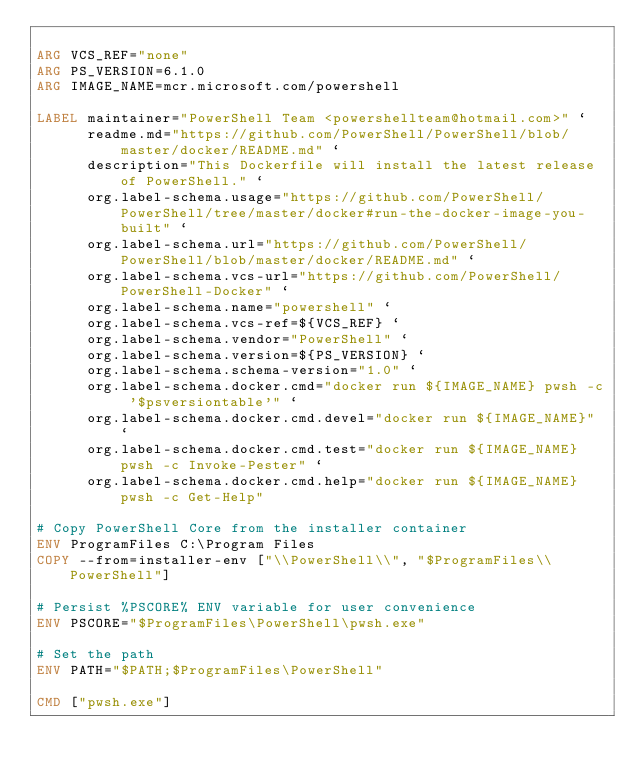<code> <loc_0><loc_0><loc_500><loc_500><_Dockerfile_>
ARG VCS_REF="none"
ARG PS_VERSION=6.1.0
ARG IMAGE_NAME=mcr.microsoft.com/powershell

LABEL maintainer="PowerShell Team <powershellteam@hotmail.com>" `
      readme.md="https://github.com/PowerShell/PowerShell/blob/master/docker/README.md" `
      description="This Dockerfile will install the latest release of PowerShell." `
      org.label-schema.usage="https://github.com/PowerShell/PowerShell/tree/master/docker#run-the-docker-image-you-built" `
      org.label-schema.url="https://github.com/PowerShell/PowerShell/blob/master/docker/README.md" `
      org.label-schema.vcs-url="https://github.com/PowerShell/PowerShell-Docker" `
      org.label-schema.name="powershell" `
      org.label-schema.vcs-ref=${VCS_REF} `
      org.label-schema.vendor="PowerShell" `
      org.label-schema.version=${PS_VERSION} `
      org.label-schema.schema-version="1.0" `
      org.label-schema.docker.cmd="docker run ${IMAGE_NAME} pwsh -c '$psversiontable'" `
      org.label-schema.docker.cmd.devel="docker run ${IMAGE_NAME}" `
      org.label-schema.docker.cmd.test="docker run ${IMAGE_NAME} pwsh -c Invoke-Pester" `
      org.label-schema.docker.cmd.help="docker run ${IMAGE_NAME} pwsh -c Get-Help"

# Copy PowerShell Core from the installer container
ENV ProgramFiles C:\Program Files
COPY --from=installer-env ["\\PowerShell\\", "$ProgramFiles\\PowerShell"]

# Persist %PSCORE% ENV variable for user convenience
ENV PSCORE="$ProgramFiles\PowerShell\pwsh.exe"

# Set the path
ENV PATH="$PATH;$ProgramFiles\PowerShell"

CMD ["pwsh.exe"]
</code> 